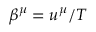Convert formula to latex. <formula><loc_0><loc_0><loc_500><loc_500>\beta ^ { \mu } = u ^ { \mu } / T</formula> 